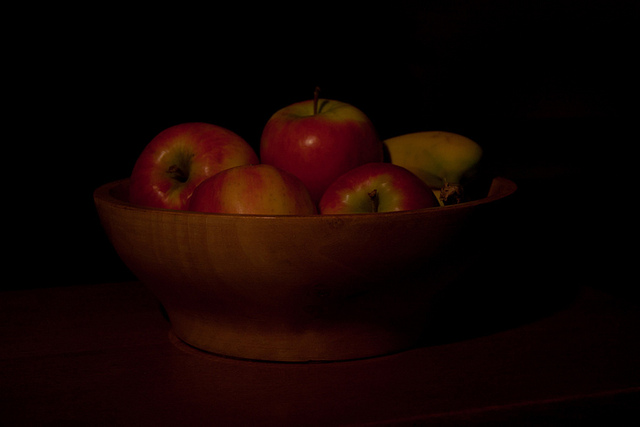<image>What utensil is resting in the bowl? There is no utensil in the bowl. However, one response suggests there could be a knife or spoon. What image does the arrangement of fruit form? I am not sure what image the arrangement of fruit forms. It could be a bowl, a circle, or just a mound. It is rather ambiguous. What utensil is resting in the bowl? It is unanswerable what utensil is resting in the bowl. What image does the arrangement of fruit form? I am not sure what image the arrangement of fruit forms. It can be seen as a centerpiece, a bowl, a basket of fruit, or a circle. 